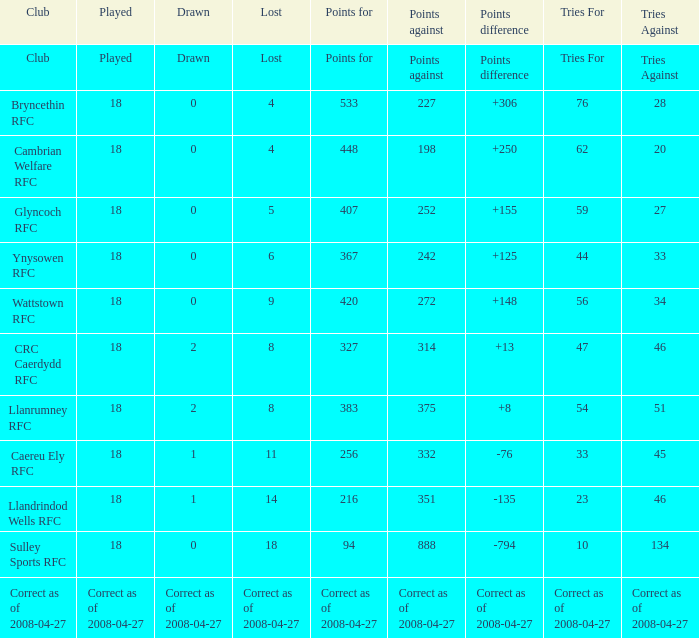What is the importance of the item "points" when the item "points against" possesses a value of 272? 420.0. I'm looking to parse the entire table for insights. Could you assist me with that? {'header': ['Club', 'Played', 'Drawn', 'Lost', 'Points for', 'Points against', 'Points difference', 'Tries For', 'Tries Against'], 'rows': [['Club', 'Played', 'Drawn', 'Lost', 'Points for', 'Points against', 'Points difference', 'Tries For', 'Tries Against'], ['Bryncethin RFC', '18', '0', '4', '533', '227', '+306', '76', '28'], ['Cambrian Welfare RFC', '18', '0', '4', '448', '198', '+250', '62', '20'], ['Glyncoch RFC', '18', '0', '5', '407', '252', '+155', '59', '27'], ['Ynysowen RFC', '18', '0', '6', '367', '242', '+125', '44', '33'], ['Wattstown RFC', '18', '0', '9', '420', '272', '+148', '56', '34'], ['CRC Caerdydd RFC', '18', '2', '8', '327', '314', '+13', '47', '46'], ['Llanrumney RFC', '18', '2', '8', '383', '375', '+8', '54', '51'], ['Caereu Ely RFC', '18', '1', '11', '256', '332', '-76', '33', '45'], ['Llandrindod Wells RFC', '18', '1', '14', '216', '351', '-135', '23', '46'], ['Sulley Sports RFC', '18', '0', '18', '94', '888', '-794', '10', '134'], ['Correct as of 2008-04-27', 'Correct as of 2008-04-27', 'Correct as of 2008-04-27', 'Correct as of 2008-04-27', 'Correct as of 2008-04-27', 'Correct as of 2008-04-27', 'Correct as of 2008-04-27', 'Correct as of 2008-04-27', 'Correct as of 2008-04-27']]} 